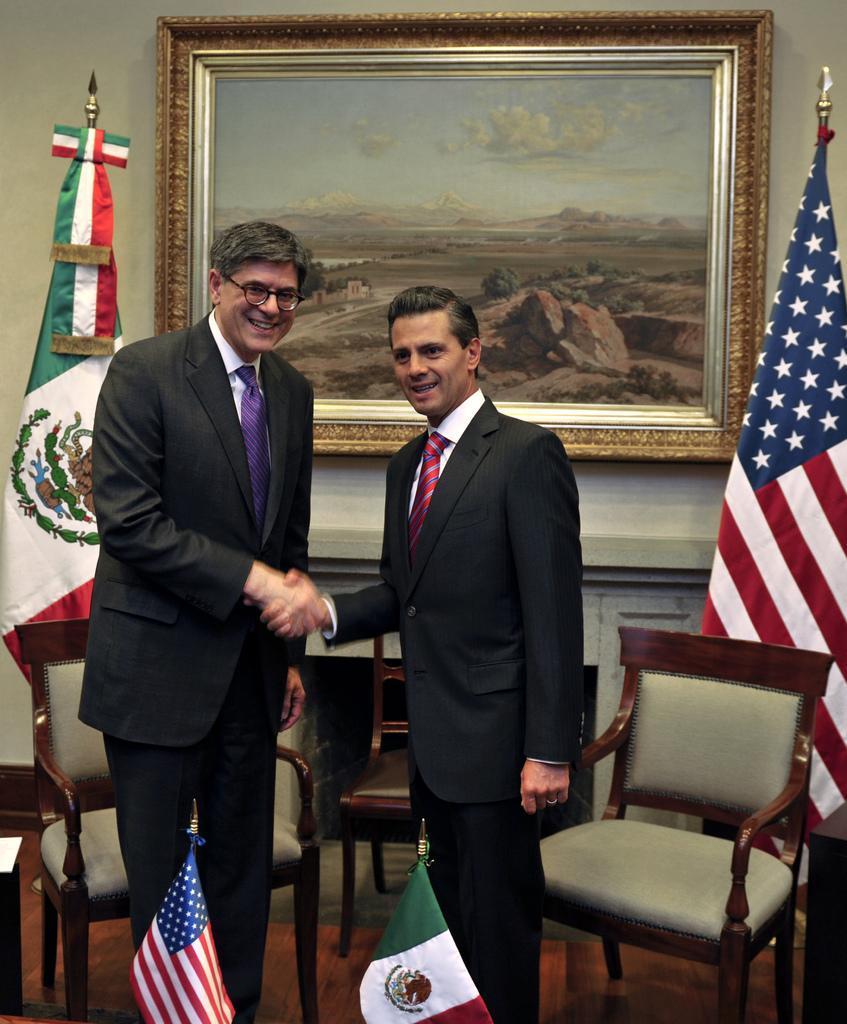Please provide a concise description of this image. In this picture we can see two men are greeting each other and also we can see a chair, flag and a wall frame. 